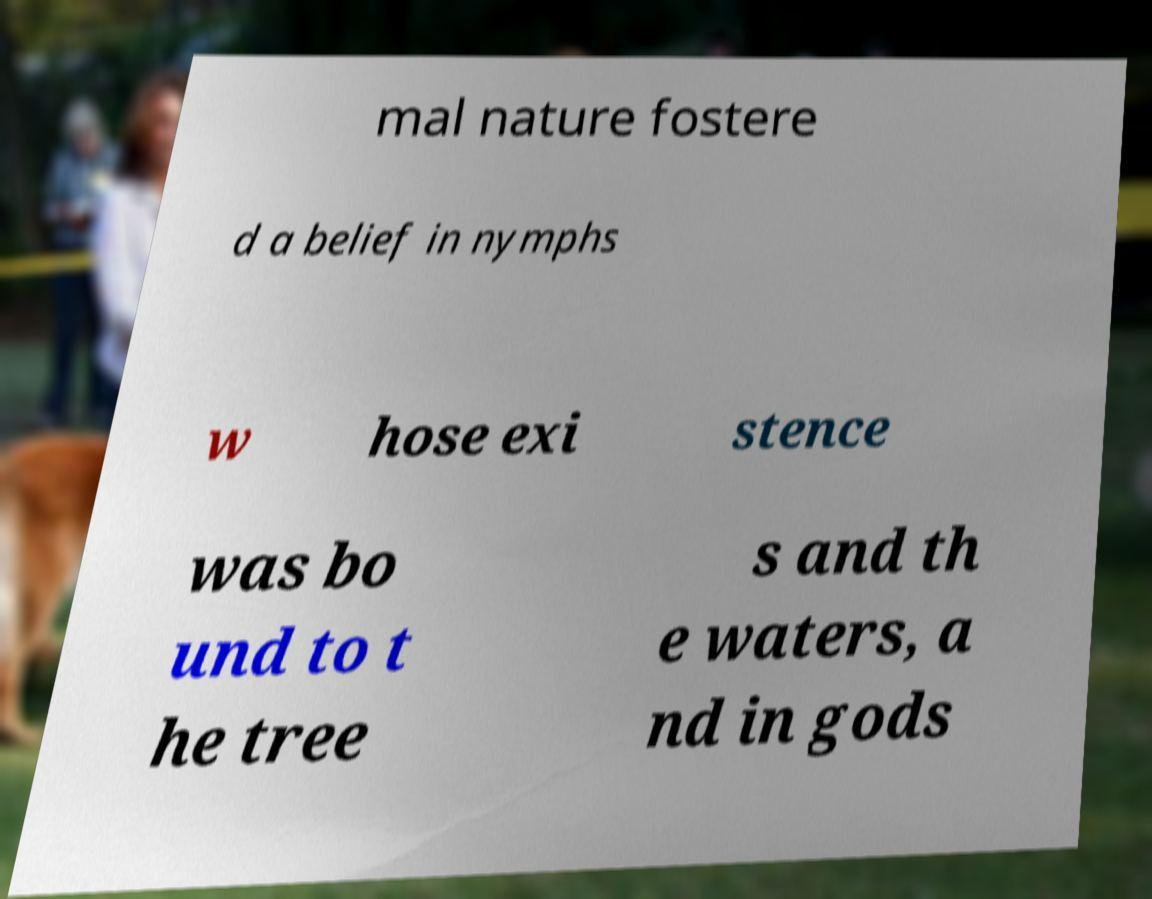Could you assist in decoding the text presented in this image and type it out clearly? mal nature fostere d a belief in nymphs w hose exi stence was bo und to t he tree s and th e waters, a nd in gods 